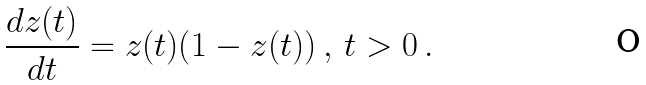Convert formula to latex. <formula><loc_0><loc_0><loc_500><loc_500>\frac { d z ( t ) } { d t } = z ( t ) ( 1 - z ( t ) ) \, , \, t > 0 \, .</formula> 